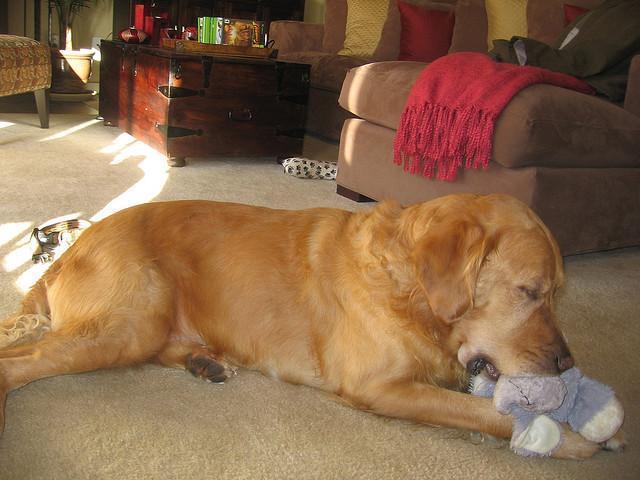How many couches are there?
Give a very brief answer. 3. How many potted plants are in the picture?
Give a very brief answer. 1. 